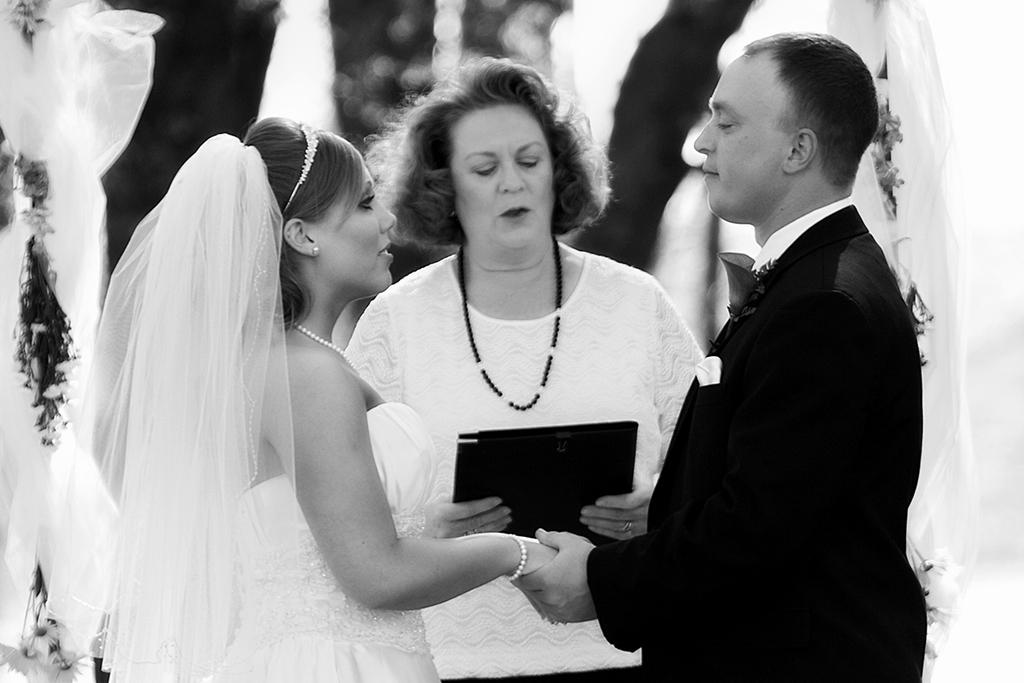How many people are in the image? There are three persons visible in the image. What is the woman holding in the image? One woman is holding a pad. Can you describe the background of the image? The background of the image is blurry. Is there any object on the left side of the image? There might be a cloth on the left side of the image. What type of apple is the woman eating in the image? There is no apple present in the image; the woman is holding a pad. What is the income of the persons in the image? The income of the persons in the image cannot be determined from the image itself. 